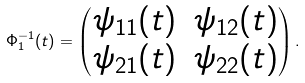Convert formula to latex. <formula><loc_0><loc_0><loc_500><loc_500>\Phi ^ { - 1 } _ { 1 } ( t ) = \begin{pmatrix} \psi _ { 1 1 } ( t ) & \psi _ { 1 2 } ( t ) \\ \psi _ { 2 1 } ( t ) & \psi _ { 2 2 } ( t ) \end{pmatrix} .</formula> 